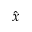<formula> <loc_0><loc_0><loc_500><loc_500>\hat { x }</formula> 